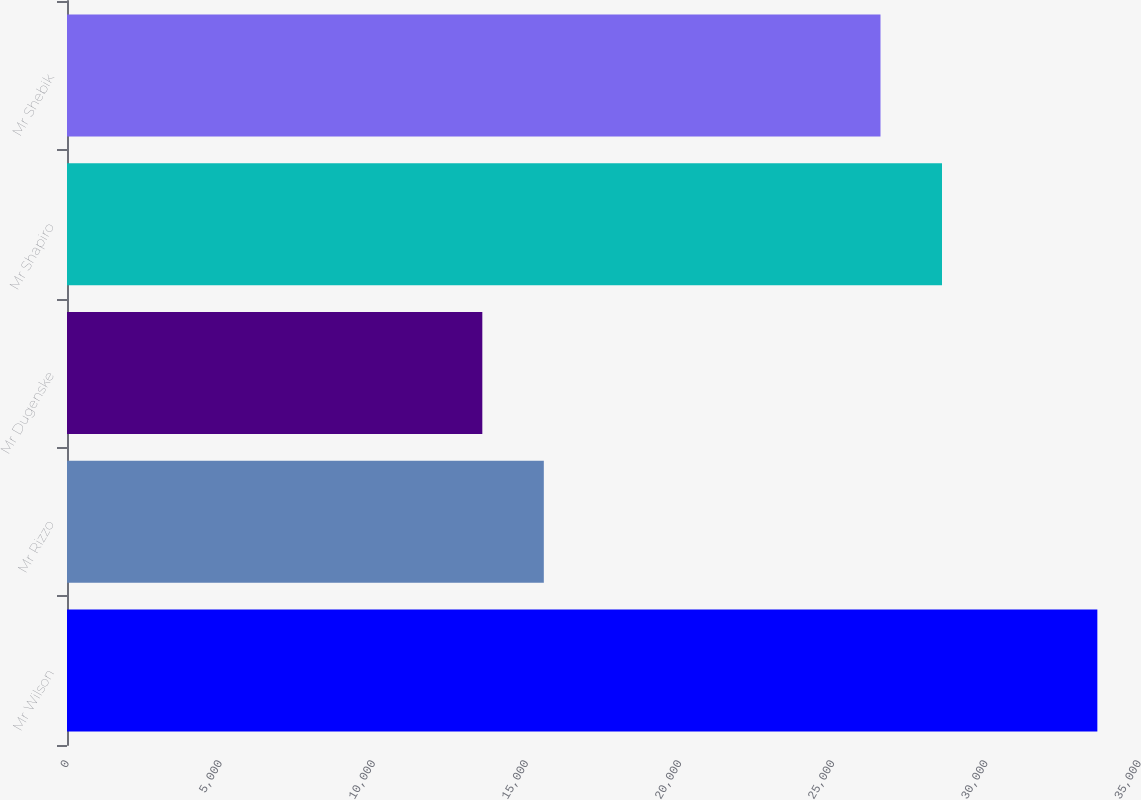<chart> <loc_0><loc_0><loc_500><loc_500><bar_chart><fcel>Mr Wilson<fcel>Mr Rizzo<fcel>Mr Dugenske<fcel>Mr Shapiro<fcel>Mr Shebik<nl><fcel>33640<fcel>15568<fcel>13560<fcel>28568<fcel>26560<nl></chart> 